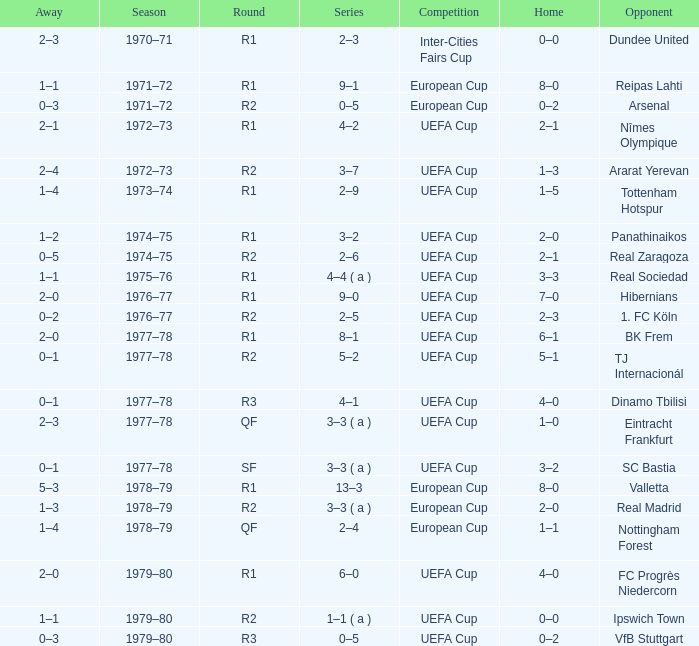Which Opponent has an Away of 1–1, and a Home of 3–3? Real Sociedad. Parse the full table. {'header': ['Away', 'Season', 'Round', 'Series', 'Competition', 'Home', 'Opponent'], 'rows': [['2–3', '1970–71', 'R1', '2–3', 'Inter-Cities Fairs Cup', '0–0', 'Dundee United'], ['1–1', '1971–72', 'R1', '9–1', 'European Cup', '8–0', 'Reipas Lahti'], ['0–3', '1971–72', 'R2', '0–5', 'European Cup', '0–2', 'Arsenal'], ['2–1', '1972–73', 'R1', '4–2', 'UEFA Cup', '2–1', 'Nîmes Olympique'], ['2–4', '1972–73', 'R2', '3–7', 'UEFA Cup', '1–3', 'Ararat Yerevan'], ['1–4', '1973–74', 'R1', '2–9', 'UEFA Cup', '1–5', 'Tottenham Hotspur'], ['1–2', '1974–75', 'R1', '3–2', 'UEFA Cup', '2–0', 'Panathinaikos'], ['0–5', '1974–75', 'R2', '2–6', 'UEFA Cup', '2–1', 'Real Zaragoza'], ['1–1', '1975–76', 'R1', '4–4 ( a )', 'UEFA Cup', '3–3', 'Real Sociedad'], ['2–0', '1976–77', 'R1', '9–0', 'UEFA Cup', '7–0', 'Hibernians'], ['0–2', '1976–77', 'R2', '2–5', 'UEFA Cup', '2–3', '1. FC Köln'], ['2–0', '1977–78', 'R1', '8–1', 'UEFA Cup', '6–1', 'BK Frem'], ['0–1', '1977–78', 'R2', '5–2', 'UEFA Cup', '5–1', 'TJ Internacionál'], ['0–1', '1977–78', 'R3', '4–1', 'UEFA Cup', '4–0', 'Dinamo Tbilisi'], ['2–3', '1977–78', 'QF', '3–3 ( a )', 'UEFA Cup', '1–0', 'Eintracht Frankfurt'], ['0–1', '1977–78', 'SF', '3–3 ( a )', 'UEFA Cup', '3–2', 'SC Bastia'], ['5–3', '1978–79', 'R1', '13–3', 'European Cup', '8–0', 'Valletta'], ['1–3', '1978–79', 'R2', '3–3 ( a )', 'European Cup', '2–0', 'Real Madrid'], ['1–4', '1978–79', 'QF', '2–4', 'European Cup', '1–1', 'Nottingham Forest'], ['2–0', '1979–80', 'R1', '6–0', 'UEFA Cup', '4–0', 'FC Progrès Niedercorn'], ['1–1', '1979–80', 'R2', '1–1 ( a )', 'UEFA Cup', '0–0', 'Ipswich Town'], ['0–3', '1979–80', 'R3', '0–5', 'UEFA Cup', '0–2', 'VfB Stuttgart']]} 